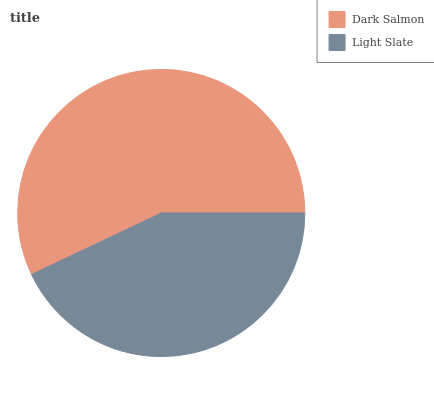Is Light Slate the minimum?
Answer yes or no. Yes. Is Dark Salmon the maximum?
Answer yes or no. Yes. Is Light Slate the maximum?
Answer yes or no. No. Is Dark Salmon greater than Light Slate?
Answer yes or no. Yes. Is Light Slate less than Dark Salmon?
Answer yes or no. Yes. Is Light Slate greater than Dark Salmon?
Answer yes or no. No. Is Dark Salmon less than Light Slate?
Answer yes or no. No. Is Dark Salmon the high median?
Answer yes or no. Yes. Is Light Slate the low median?
Answer yes or no. Yes. Is Light Slate the high median?
Answer yes or no. No. Is Dark Salmon the low median?
Answer yes or no. No. 